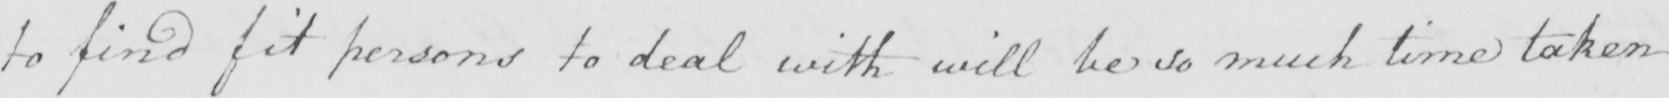Can you tell me what this handwritten text says? to find fit persons to deal with will be so much time taken 